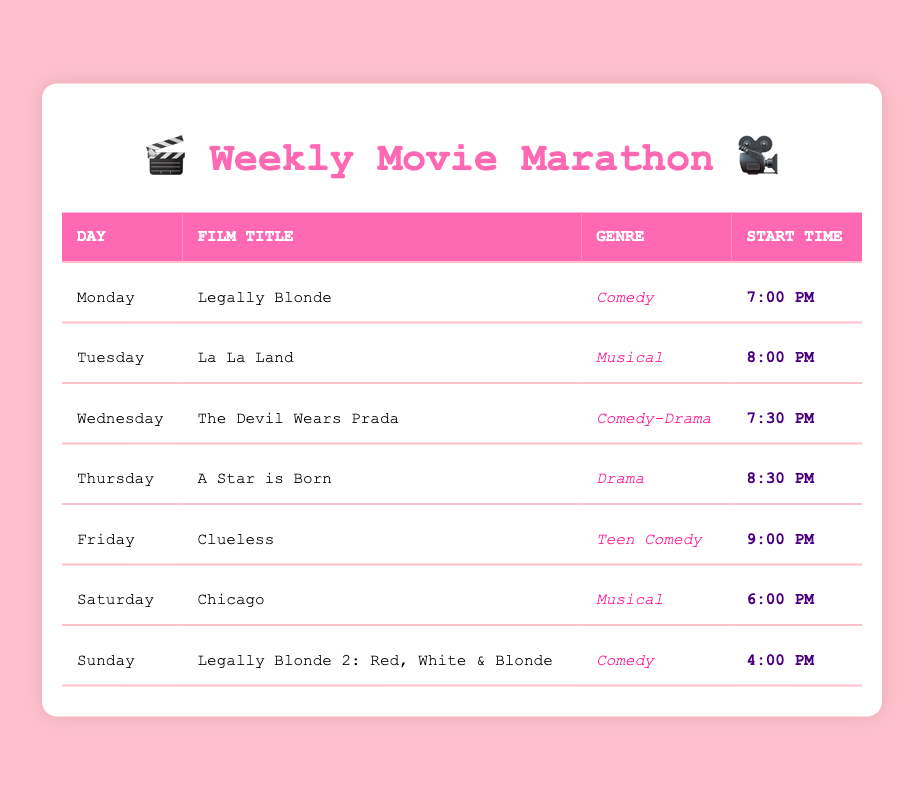What film is scheduled for Friday? The table shows each day's film title. On the row for Friday, the film title listed is "Clueless."
Answer: Clueless What is the genre of "La La Land"? Referring to the row for Tuesday, the genre associated with "La La Land" is listed as "Musical."
Answer: Musical On which day does "Legally Blonde 2: Red, White & Blonde" start? The table indicates that "Legally Blonde 2: Red, White & Blonde" is scheduled for Sunday.
Answer: Sunday How many Comedy films are in the schedule? The films labeled as "Comedy" in the table are "Legally Blonde" (Monday) and "Legally Blonde 2: Red, White & Blonde" (Sunday). There are 2 such films.
Answer: 2 Is "The Devil Wears Prada" scheduled for the same time as "A Star is Born"? "The Devil Wears Prada" starts at 7:30 PM on Wednesday, while "A Star is Born" starts at 8:30 PM on Thursday. Since the times are different, the answer is no.
Answer: No What is the latest start time for a film during the week? The latest start time in the schedule is 9:00 PM, which corresponds to "Clueless" on Friday.
Answer: 9:00 PM How many of the films listed are categorized as musicals? The table shows two films identified as musicals: "La La Land" on Tuesday and "Chicago" on Saturday, making a total of 2 musicals.
Answer: 2 On what days are the Comedy films scheduled? "Legally Blonde" is scheduled on Monday and "Legally Blonde 2: Red, White & Blonde" is scheduled on Sunday, making those the days for Comedy films.
Answer: Monday and Sunday Which film is positioned at the mid-point of the week? Wednesday falls in the middle of the week, and the film scheduled for that day is "The Devil Wears Prada."
Answer: The Devil Wears Prada 